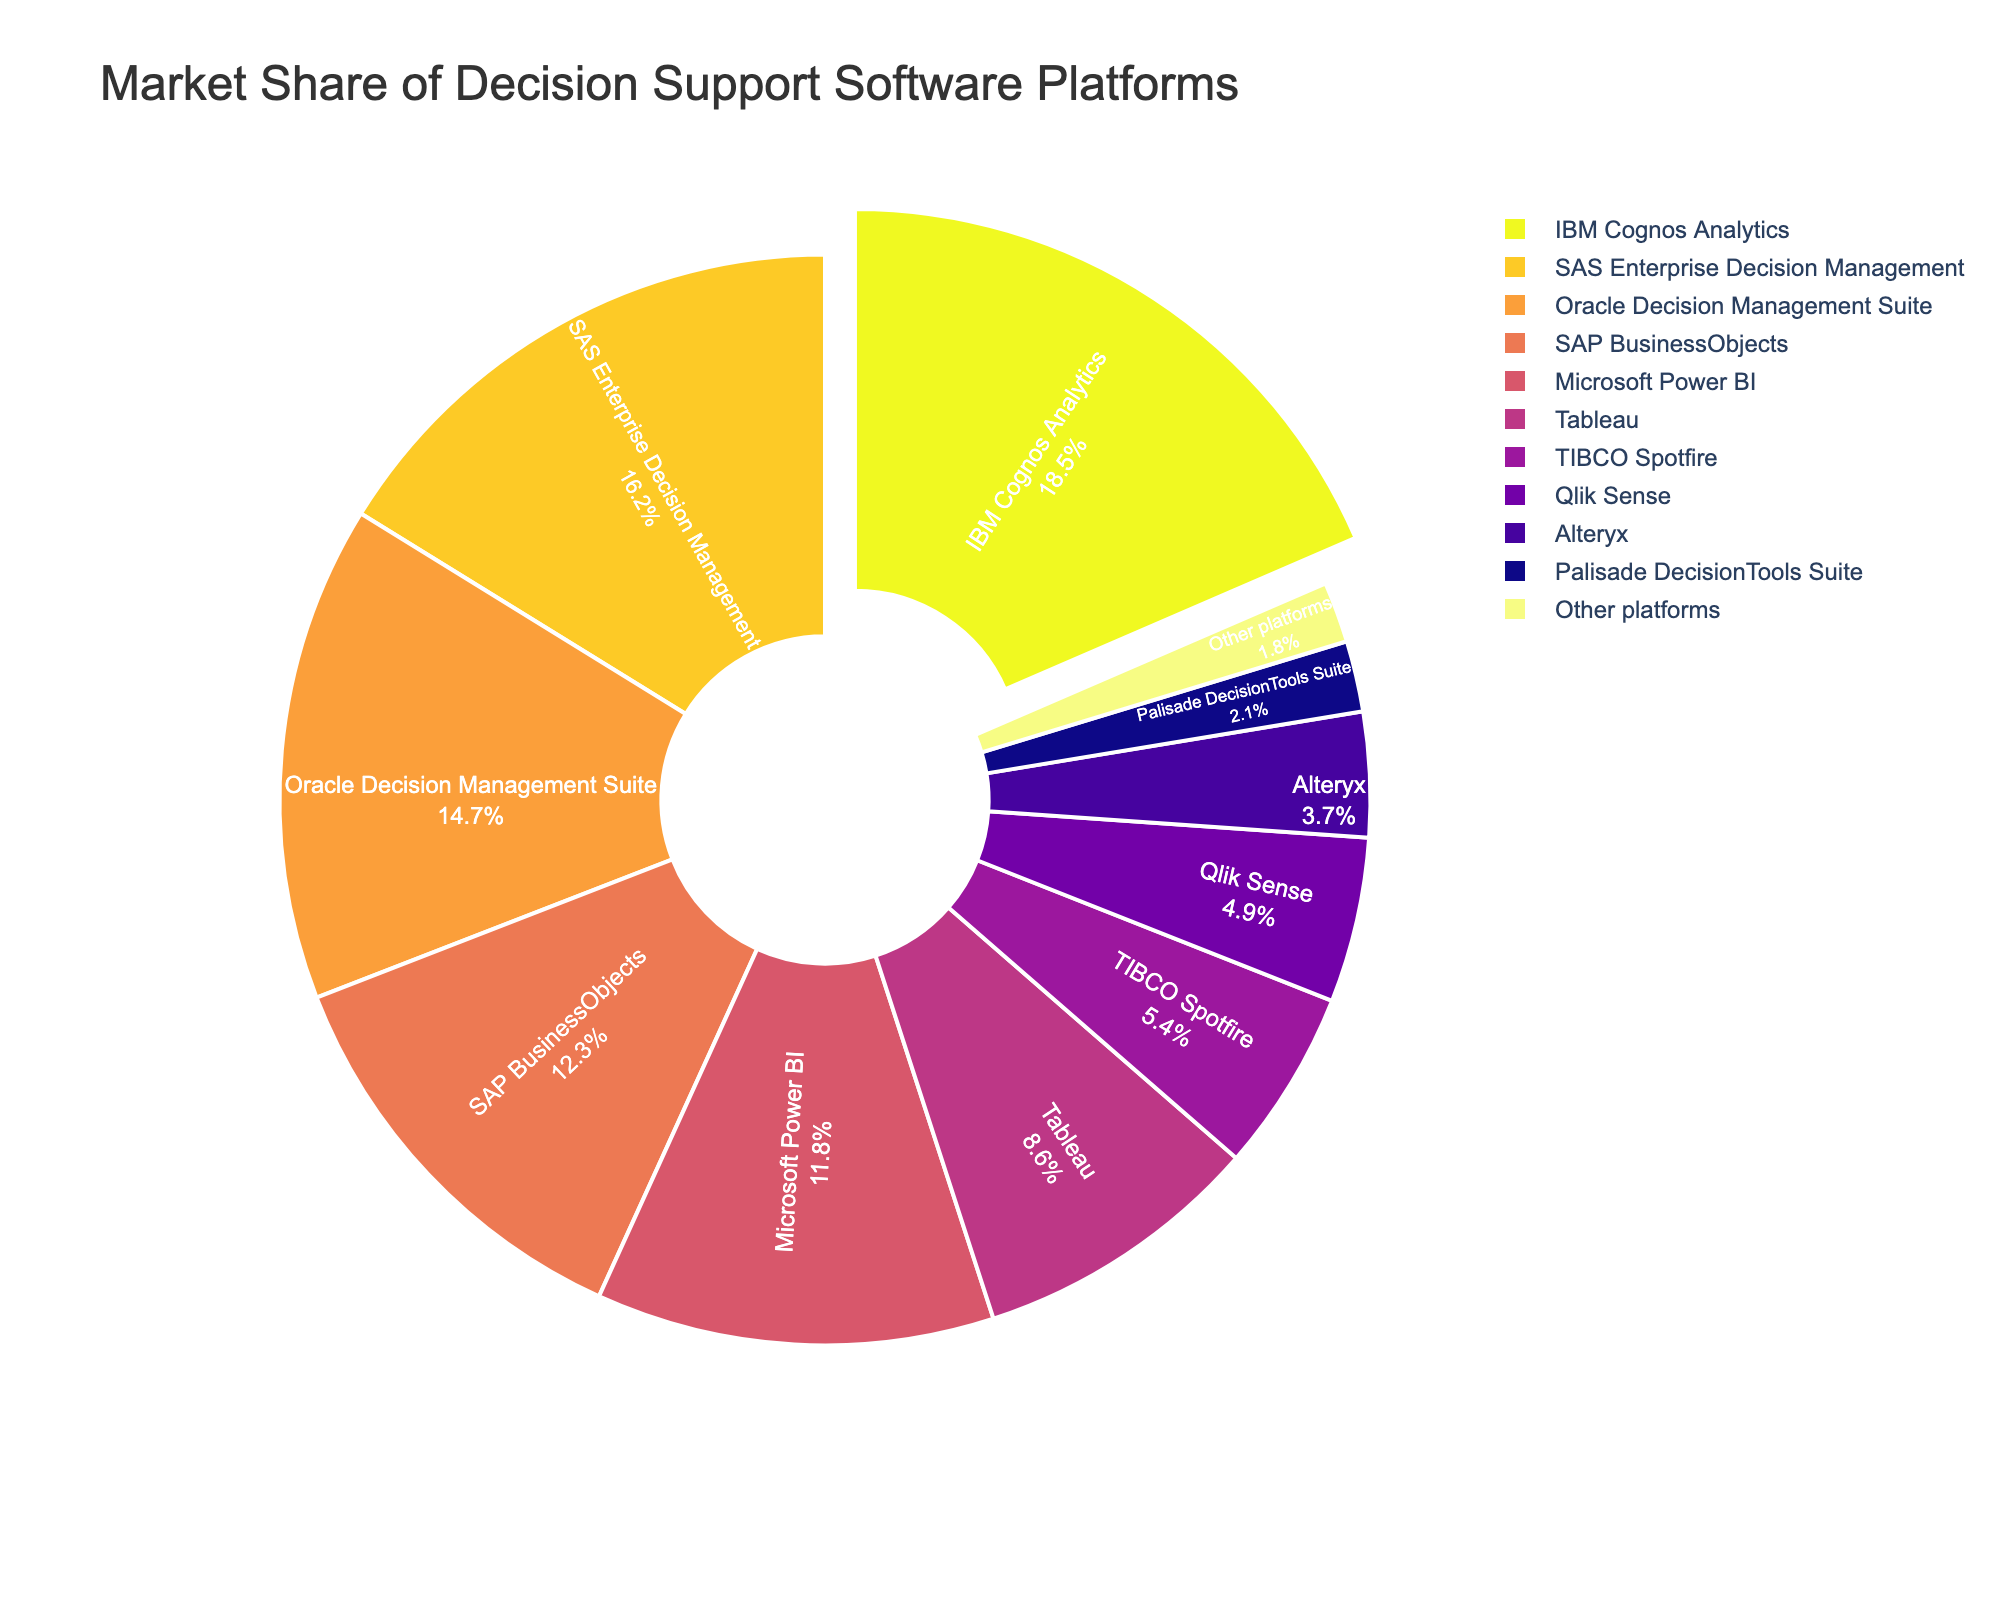Which software platform has the largest market share? The figure shows a pie chart where the market share percentages are labeled. The slice with "IBM Cognos Analytics" is visually the largest and has the highest percentage value of 18.5.
Answer: IBM Cognos Analytics Which two software platforms together contribute to a market share of over 30%? Adding the market shares of the top two platforms, IBM Cognos Analytics (18.5) and SAS Enterprise Decision Management (16.2), gives a total of 34.7, which is over 30%.
Answer: IBM Cognos Analytics and SAS Enterprise Decision Management How does the market share of Microsoft Power BI compare to that of SAP BusinessObjects? The pie chart shows the market share percentages for both platforms: Microsoft Power BI has 11.8% while SAP BusinessObjects has 12.3%. SAP BusinessObjects has a slightly larger market share compared to Microsoft Power BI.
Answer: SAP BusinessObjects is greater What is the combined market share of the platforms that have less than 5% individually? Adding the percentages of TIBCO Spotfire (5.4), Qlik Sense (4.9), Alteryx (3.7), Palisade DecisionTools Suite (2.1), and Other platforms (1.8) gives a total of 17.9%. However, TIBCO Spotfire at 5.4% should not be included. So, the combined share is 4.9 + 3.7 + 2.1 + 1.8 = 12.5.
Answer: 12.5% Which platform's market share is closest to 10%? The pie chart shows percentages, and among them, Tableau has a market share of 8.6%, which is closest to 10%.
Answer: Tableau What is the difference in market share between the platform with the highest share and the platform with the lowest share? The highest market share is IBM Cognos Analytics at 18.5% and the lowest is Other platforms at 1.8%. The difference is 18.5 - 1.8 = 16.7.
Answer: 16.7 If the market share of Oracle Decision Management Suite increased by 6%, what would its new market share be? Currently, Oracle Decision Management Suite has 14.7%. Adding 6% to this gives a new market share of 14.7 + 6 = 20.7%.
Answer: 20.7% What portion of the chart is highlighted or pulled out, and what platform does it represent? The pie chart's description indicates that the slice for "IBM Cognos Analytics" is pulled out, which is visually highlighted.
Answer: IBM Cognos Analytics 